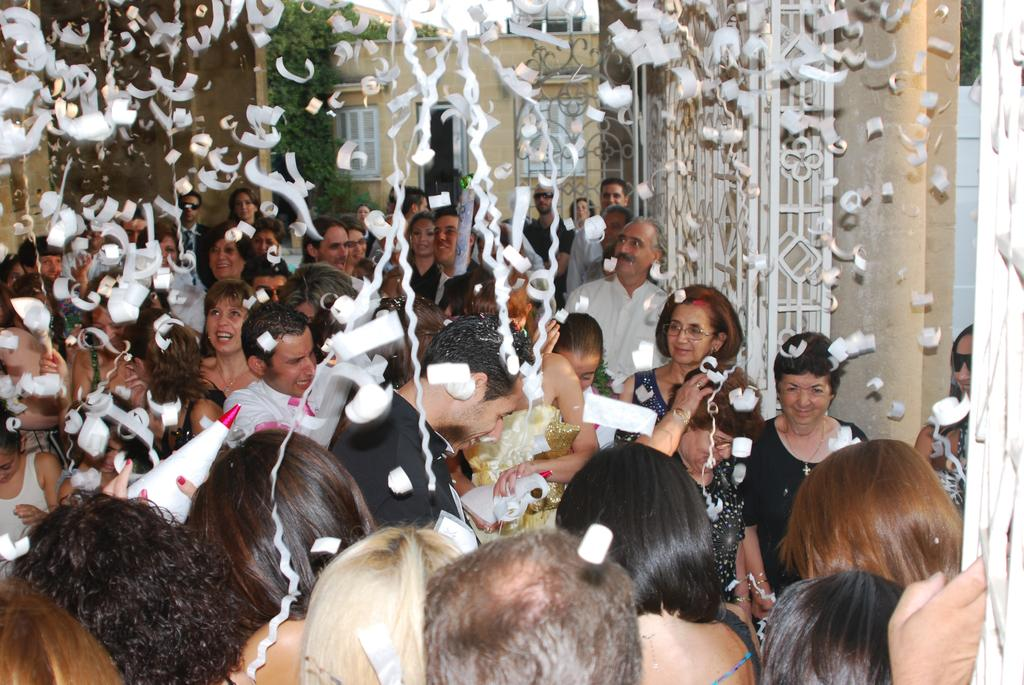Who or what can be seen in the image? There are people in the image. What decorations are present in the image? There are streamers in the image. What can be seen in the background of the image? There is a building, a tree, and a grille in the background of the image. What thought is the minister having while standing next to the grille in the image? There is no minister present in the image, and therefore no thoughts can be attributed to them. 